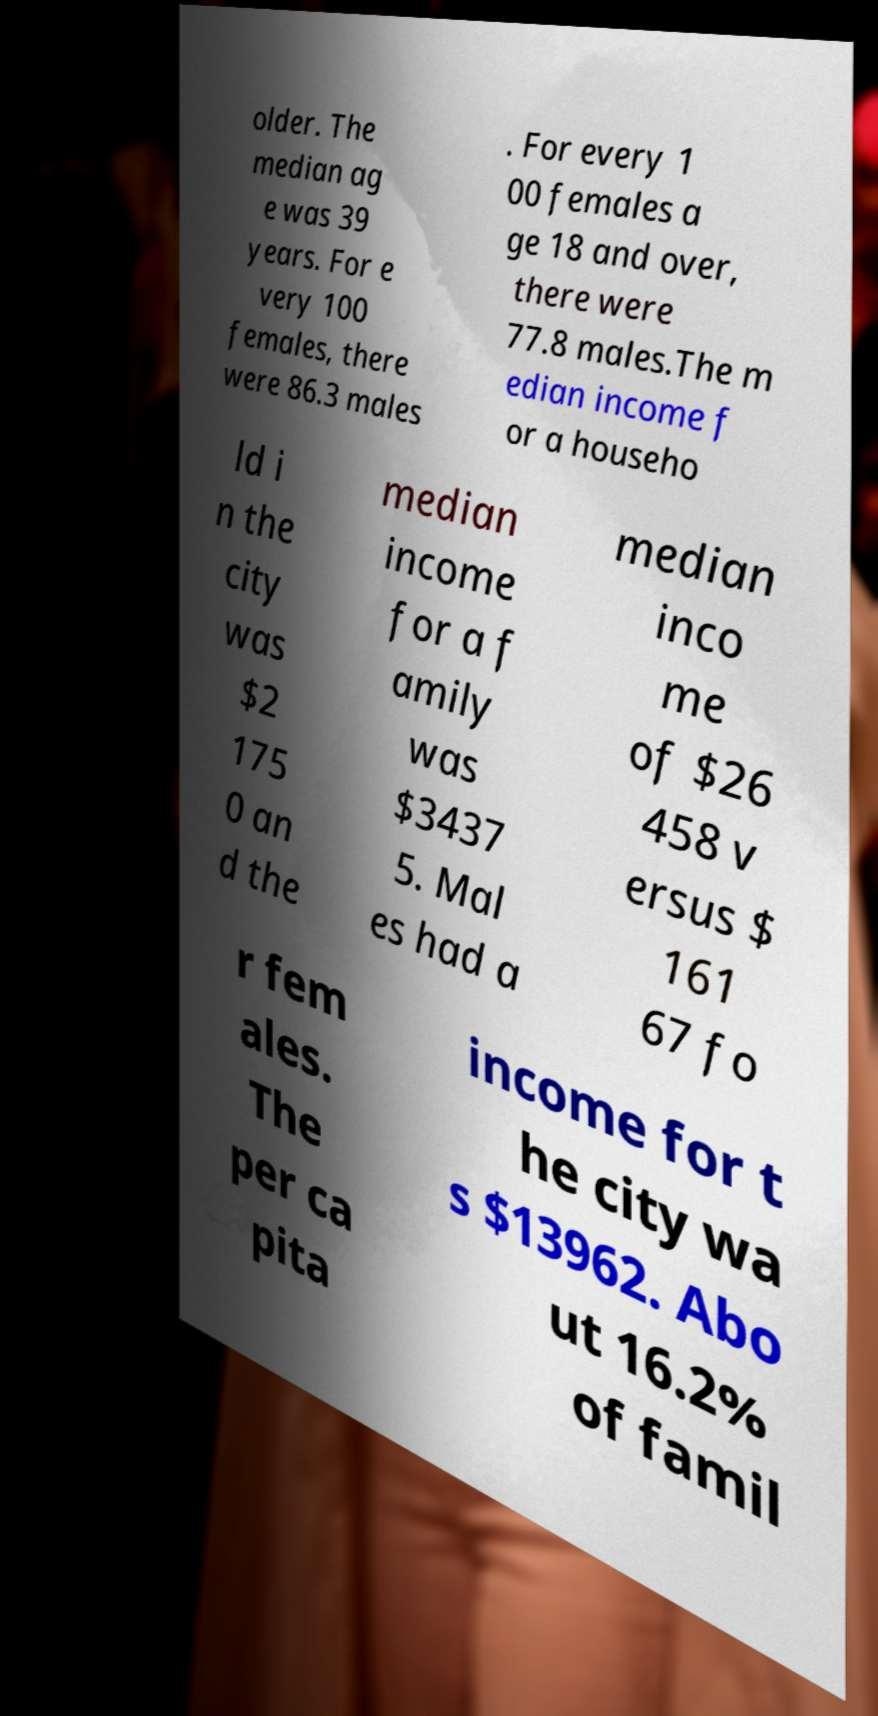Could you extract and type out the text from this image? older. The median ag e was 39 years. For e very 100 females, there were 86.3 males . For every 1 00 females a ge 18 and over, there were 77.8 males.The m edian income f or a househo ld i n the city was $2 175 0 an d the median income for a f amily was $3437 5. Mal es had a median inco me of $26 458 v ersus $ 161 67 fo r fem ales. The per ca pita income for t he city wa s $13962. Abo ut 16.2% of famil 